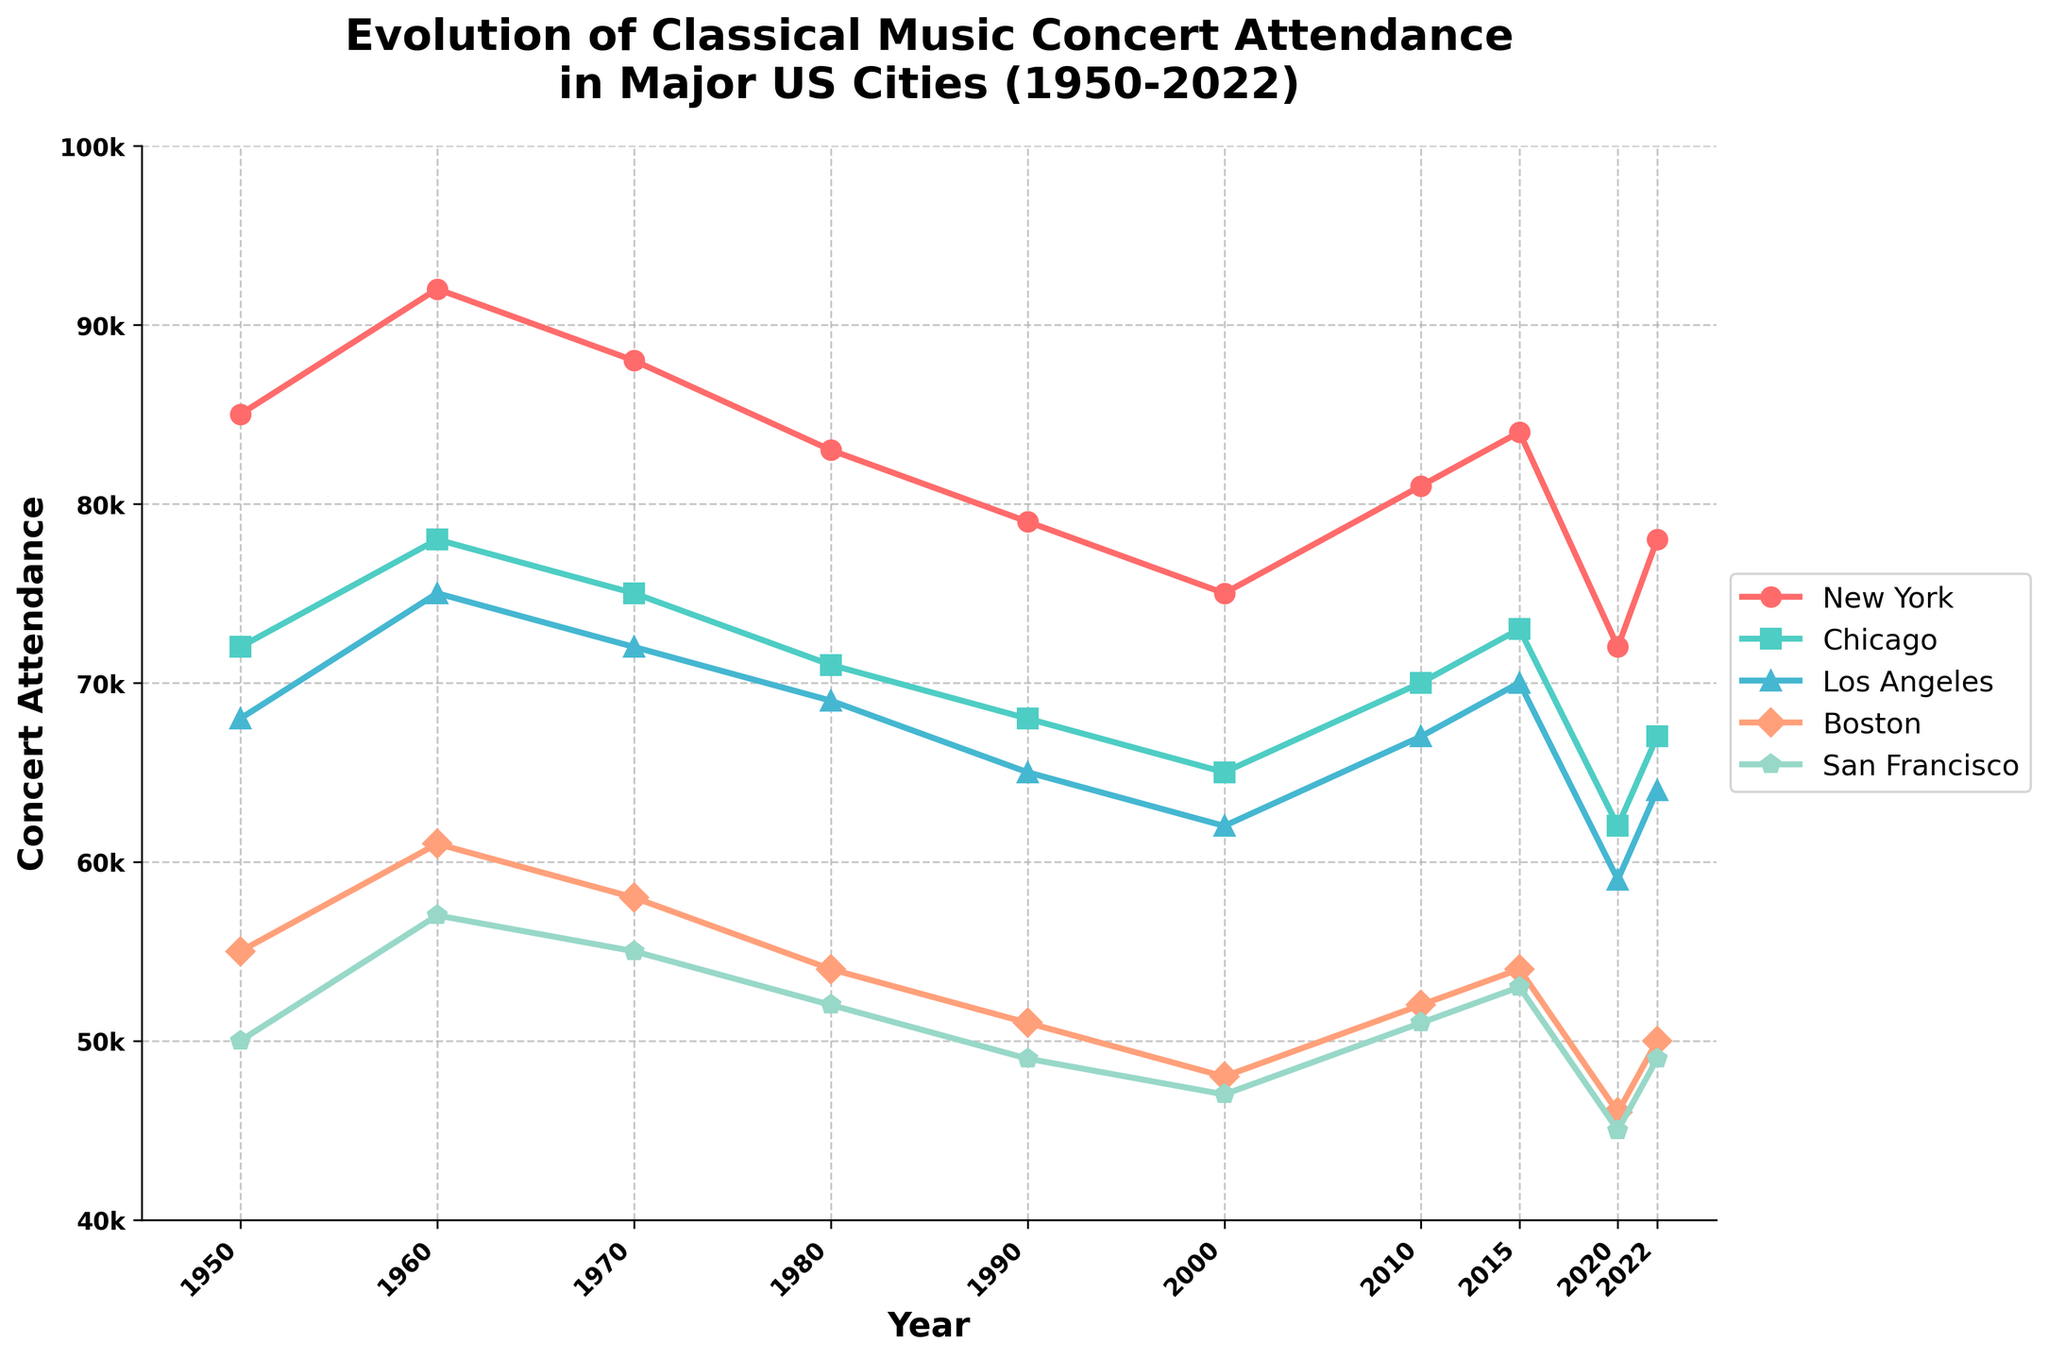What city saw the highest concert attendance in 1980? The chart indicates classical music concert attendance for each of the five major cities over the years. Looking at the year 1980, the tallest bar corresponds to New York.
Answer: New York Which city experienced the steepest decline in concert attendance from 2015 to 2020? By comparing the slopes of the lines between the years 2015 and 2020 for each city, Los Angeles shows the steepest decline with a significant drop.
Answer: Los Angeles What is the average concert attendance across all cities in the year 2000? To find the average for the year 2000, add the values for each city and then divide by the number of cities. (75000 + 65000 + 62000 + 48000 + 47000) / 5 = 59400
Answer: 59400 How did San Francisco's concert attendance change from 1950 to 2022? In 1950, San Francisco's attendance was 50000; in 2022, it was 49000. The attendance decreased by 1000 over this period.
Answer: Decreased by 1000 Which city had the smallest concert attendance in 2022 and what was the value? For the year 2022, the line corresponding to San Francisco is the lowest among all cities, with a value of 49000.
Answer: San Francisco, 49000 Did any city experience an overall increase in concert attendance from 1950 to 2022? By looking at the trends from 1950 to 2022 for each city, one can see that none of the cities show an overall increase; all have decreased or fluctuated downward.
Answer: No What was the concert attendance in Boston in 1970, and how does it compare to 2020? In 1970, Boston's attendance was 58000. In 2020, it was 46000. The change is 46000 - 58000 = -12000, reflecting a decrease of 12000.
Answer: 1970: 58000, 2020: 46000, decrease of 12000 What city had the highest average concert attendance from 1950 to present? To find this, compute the average attendance over all years for each city and compare. New York has the highest average with (85000 + 92000 + 88000 + 83000 + 79000 + 75000 + 81000 + 84000 + 72000 + 78000) / 10 = 83700.
Answer: New York Which year recorded the highest average concert attendance across all cities? Compute the average attendance for each year and compare. 1960 has the highest average: (92000 + 78000 + 75000 + 61000 + 57000) / 5 = 72600.
Answer: 1960 